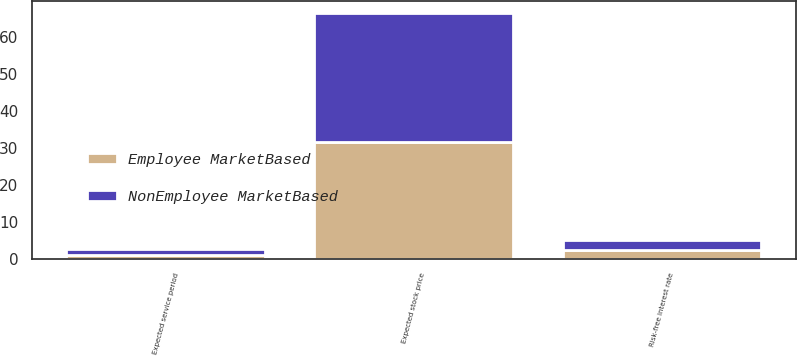<chart> <loc_0><loc_0><loc_500><loc_500><stacked_bar_chart><ecel><fcel>Risk-free interest rate<fcel>Expected stock price<fcel>Expected service period<nl><fcel>NonEmployee MarketBased<fcel>2.6<fcel>34.9<fcel>1.5<nl><fcel>Employee MarketBased<fcel>2.4<fcel>31.4<fcel>1<nl></chart> 